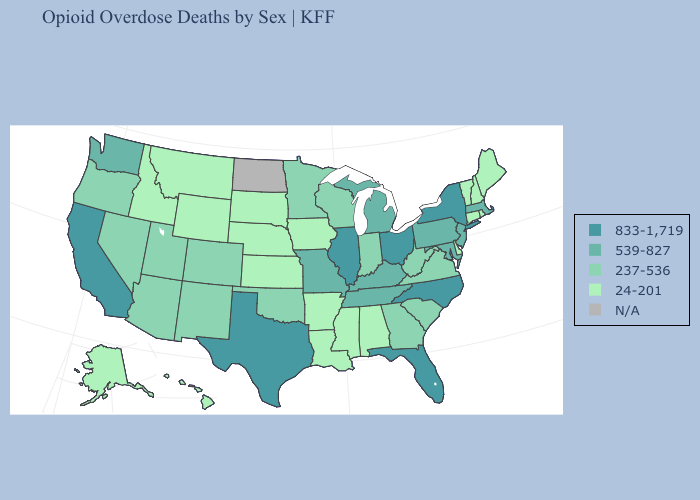Is the legend a continuous bar?
Short answer required. No. Does the map have missing data?
Answer briefly. Yes. Which states have the highest value in the USA?
Be succinct. California, Florida, Illinois, New York, North Carolina, Ohio, Texas. What is the lowest value in the Northeast?
Be succinct. 24-201. What is the lowest value in states that border Georgia?
Short answer required. 24-201. Among the states that border Kansas , which have the lowest value?
Quick response, please. Nebraska. Does the map have missing data?
Answer briefly. Yes. What is the value of North Dakota?
Keep it brief. N/A. What is the value of New Hampshire?
Give a very brief answer. 24-201. What is the lowest value in the USA?
Answer briefly. 24-201. What is the value of Florida?
Keep it brief. 833-1,719. Name the states that have a value in the range 237-536?
Quick response, please. Arizona, Colorado, Georgia, Indiana, Minnesota, Nevada, New Mexico, Oklahoma, Oregon, South Carolina, Utah, Virginia, West Virginia, Wisconsin. Does Florida have the highest value in the South?
Be succinct. Yes. Which states have the lowest value in the South?
Give a very brief answer. Alabama, Arkansas, Delaware, Louisiana, Mississippi. Does the first symbol in the legend represent the smallest category?
Be succinct. No. 